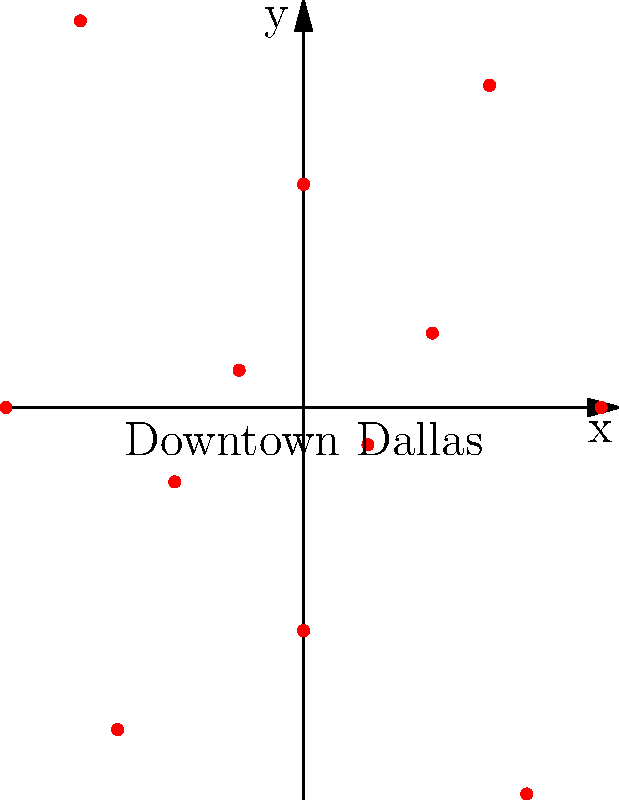In the polar rose diagram above, which represents the distribution of hidden spots around downtown Dallas, what is the angle (in degrees) between the two hidden spots that are farthest from the city center? To solve this problem, we need to follow these steps:

1. Identify the two points that are farthest from the center (0,0).
2. Determine their angles on the polar coordinate system.
3. Calculate the difference between these angles.

From the given data:
- The distances are: 4, 2, 5, 3, 6, 1, 4, 2, 5, 3, 6, 1
- The corresponding angles are: 0°, 30°, 60°, 90°, 120°, 150°, 180°, 210°, 240°, 270°, 300°, 330°

The maximum distance is 6, which occurs twice:
1. At 120°
2. At 300°

To find the angle between these two points, we subtract the smaller angle from the larger:

$300° - 120° = 180°$

Therefore, the angle between the two hidden spots that are farthest from downtown Dallas is 180°.
Answer: 180° 